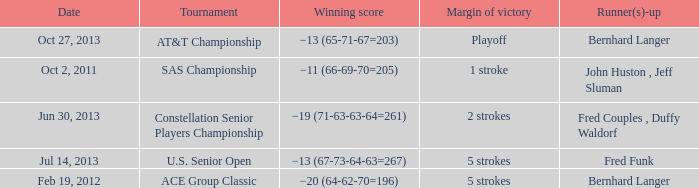Which Date has a Runner(s)-up of bernhard langer, and a Tournament of at&t championship? Oct 27, 2013. 